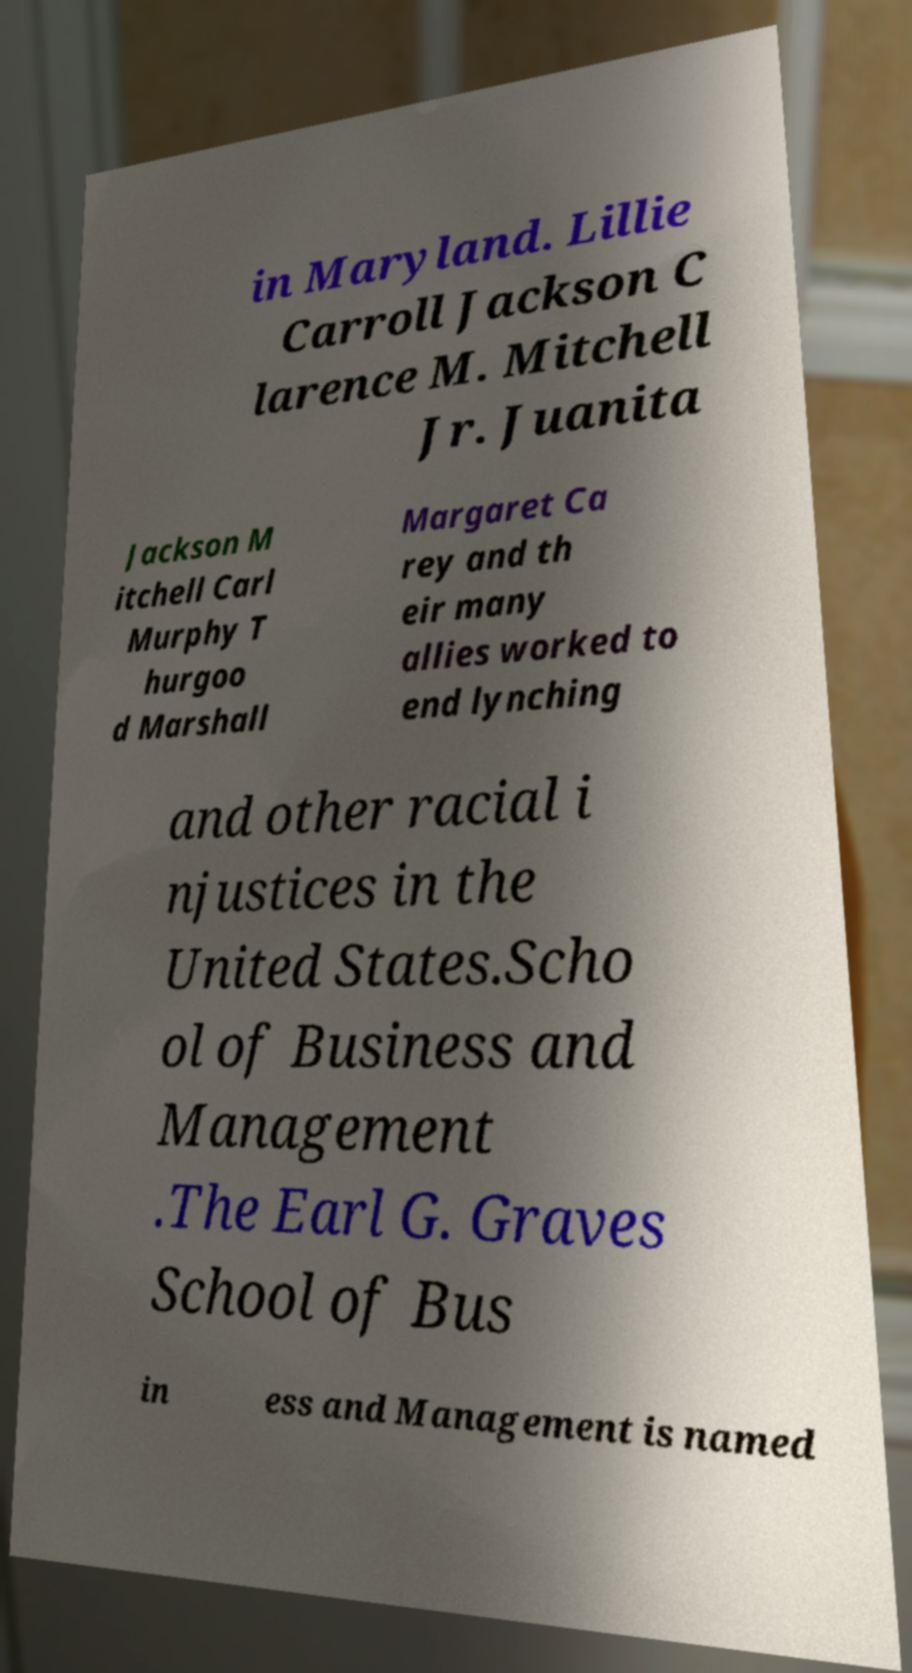What messages or text are displayed in this image? I need them in a readable, typed format. in Maryland. Lillie Carroll Jackson C larence M. Mitchell Jr. Juanita Jackson M itchell Carl Murphy T hurgoo d Marshall Margaret Ca rey and th eir many allies worked to end lynching and other racial i njustices in the United States.Scho ol of Business and Management .The Earl G. Graves School of Bus in ess and Management is named 